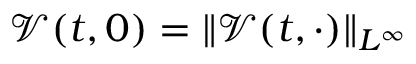<formula> <loc_0><loc_0><loc_500><loc_500>\mathcal { V } ( t , 0 ) = \| \mathcal { V } ( t , \cdot ) \| _ { L ^ { \infty } }</formula> 